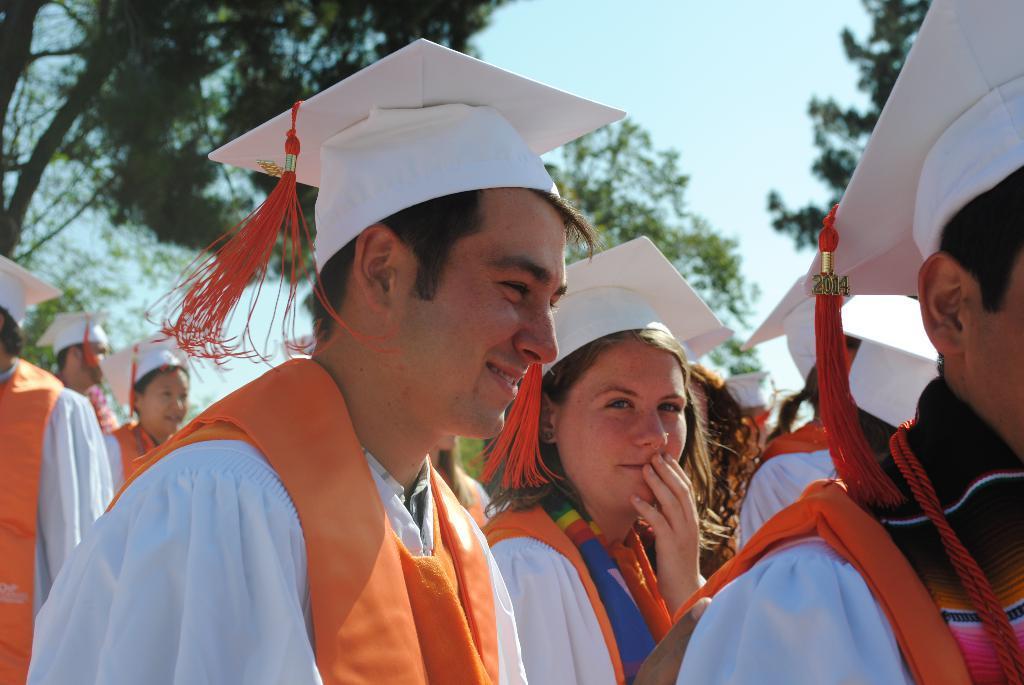Please provide a concise description of this image. In this image we can see group of people wore white and orange combination dress and white color hat. On the top left we can see trees. 